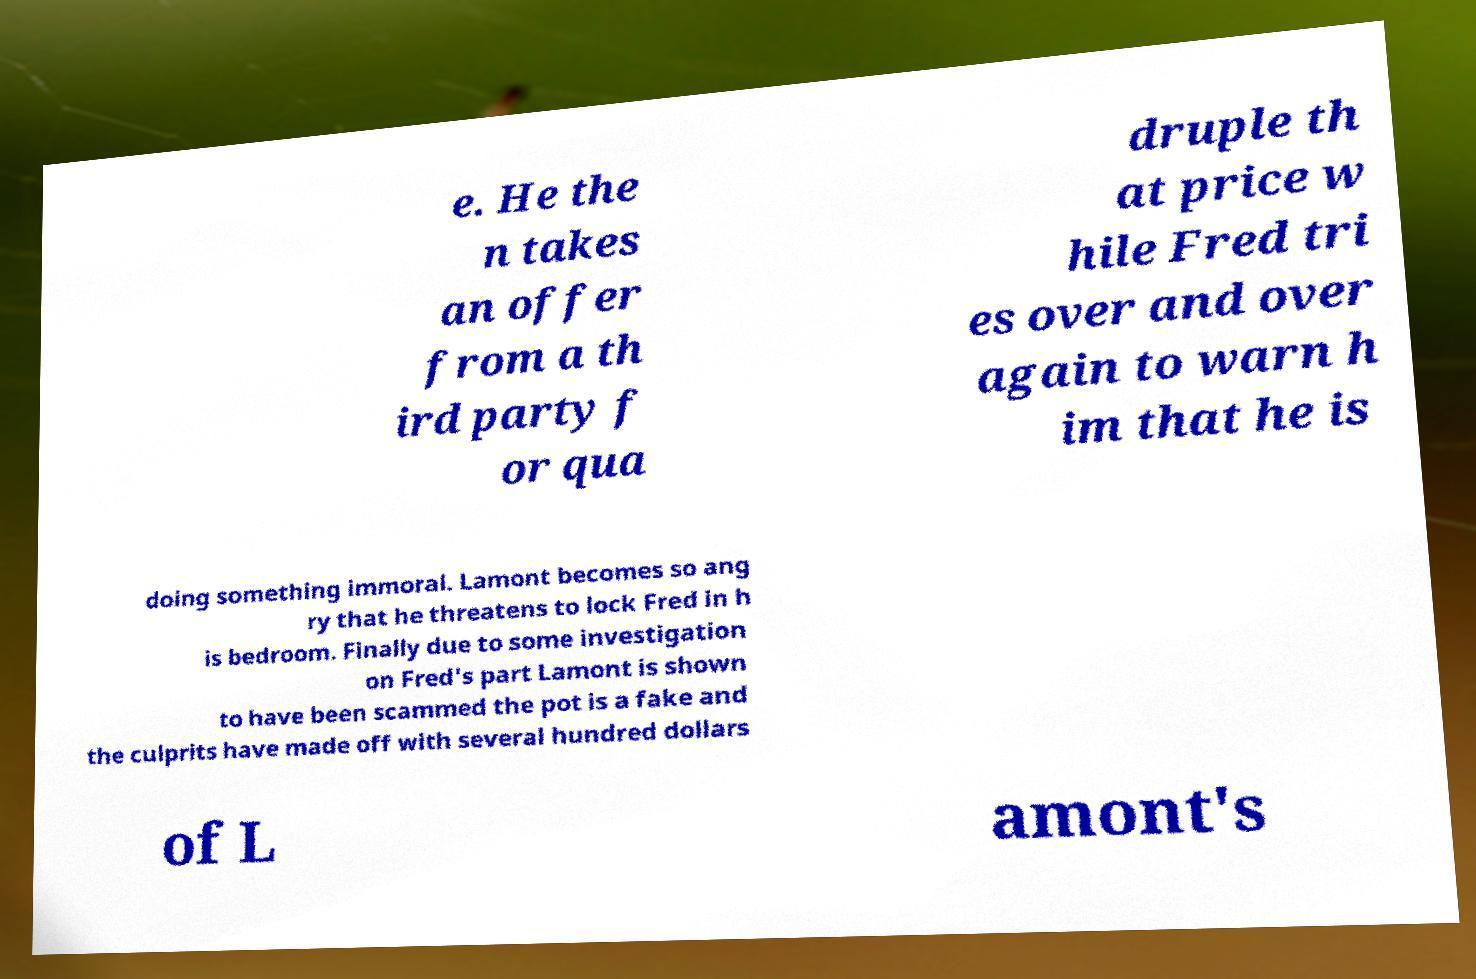I need the written content from this picture converted into text. Can you do that? e. He the n takes an offer from a th ird party f or qua druple th at price w hile Fred tri es over and over again to warn h im that he is doing something immoral. Lamont becomes so ang ry that he threatens to lock Fred in h is bedroom. Finally due to some investigation on Fred's part Lamont is shown to have been scammed the pot is a fake and the culprits have made off with several hundred dollars of L amont's 